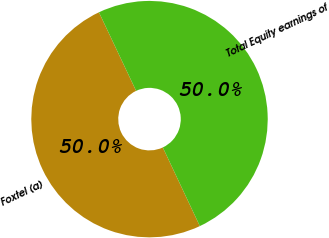<chart> <loc_0><loc_0><loc_500><loc_500><pie_chart><fcel>Foxtel (a)<fcel>Total Equity earnings of<nl><fcel>49.97%<fcel>50.03%<nl></chart> 